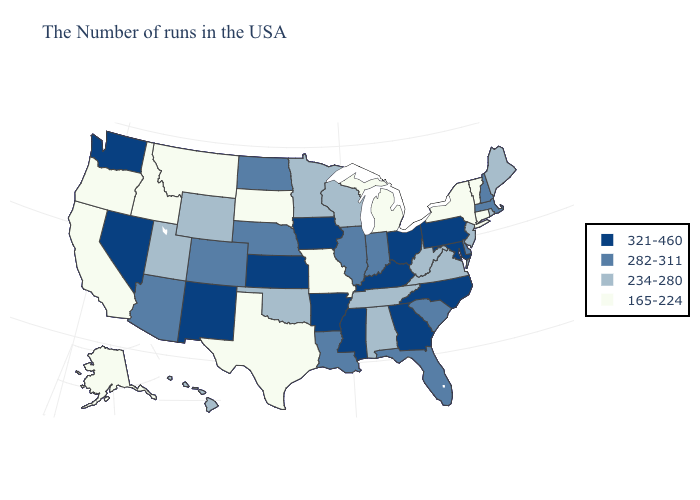Does the map have missing data?
Short answer required. No. Is the legend a continuous bar?
Give a very brief answer. No. Does the first symbol in the legend represent the smallest category?
Be succinct. No. What is the lowest value in the Northeast?
Quick response, please. 165-224. What is the lowest value in states that border Utah?
Write a very short answer. 165-224. Among the states that border Wisconsin , does Illinois have the highest value?
Be succinct. No. Does Montana have a lower value than South Carolina?
Answer briefly. Yes. What is the value of Connecticut?
Quick response, please. 165-224. Name the states that have a value in the range 234-280?
Keep it brief. Maine, Rhode Island, New Jersey, Virginia, West Virginia, Alabama, Tennessee, Wisconsin, Minnesota, Oklahoma, Wyoming, Utah, Hawaii. Name the states that have a value in the range 234-280?
Write a very short answer. Maine, Rhode Island, New Jersey, Virginia, West Virginia, Alabama, Tennessee, Wisconsin, Minnesota, Oklahoma, Wyoming, Utah, Hawaii. Does New York have a lower value than Connecticut?
Answer briefly. No. What is the highest value in states that border South Dakota?
Short answer required. 321-460. Among the states that border Minnesota , which have the lowest value?
Be succinct. South Dakota. Name the states that have a value in the range 321-460?
Short answer required. Maryland, Pennsylvania, North Carolina, Ohio, Georgia, Kentucky, Mississippi, Arkansas, Iowa, Kansas, New Mexico, Nevada, Washington. 